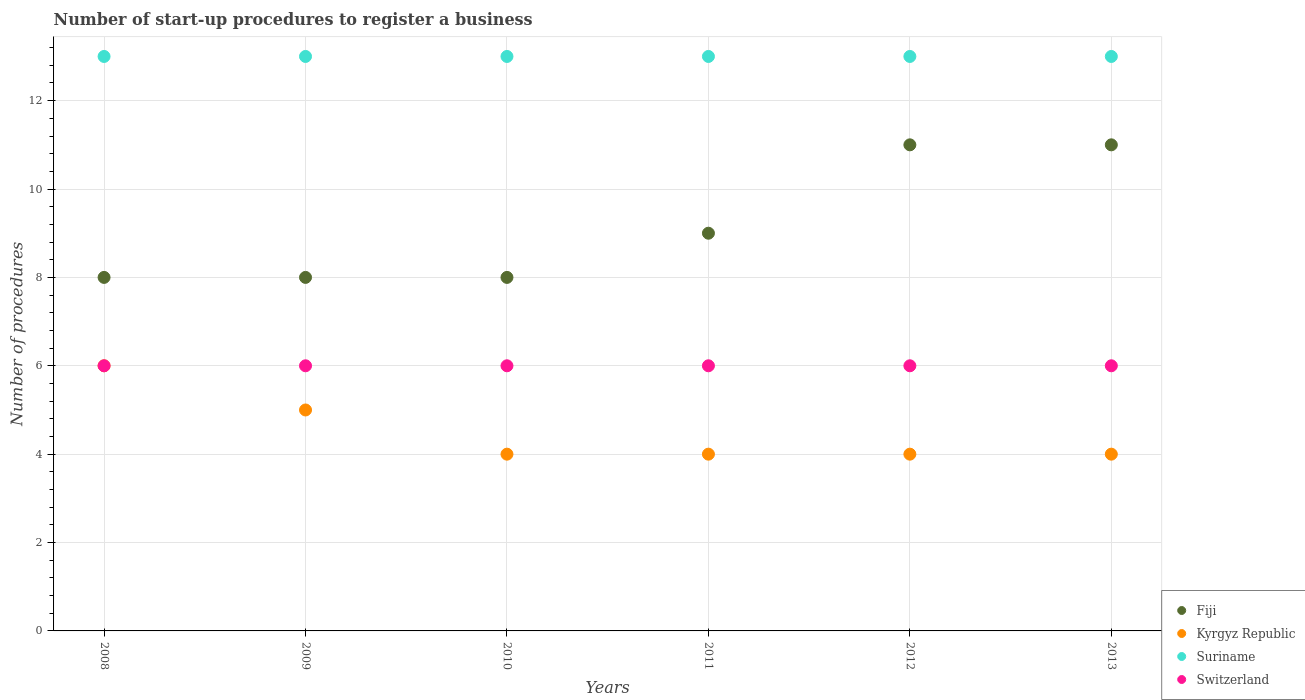How many different coloured dotlines are there?
Provide a short and direct response. 4. Is the number of dotlines equal to the number of legend labels?
Ensure brevity in your answer.  Yes. What is the number of procedures required to register a business in Fiji in 2010?
Make the answer very short. 8. Across all years, what is the minimum number of procedures required to register a business in Kyrgyz Republic?
Give a very brief answer. 4. In which year was the number of procedures required to register a business in Fiji minimum?
Give a very brief answer. 2008. What is the total number of procedures required to register a business in Switzerland in the graph?
Make the answer very short. 36. What is the difference between the number of procedures required to register a business in Suriname in 2009 and that in 2013?
Offer a terse response. 0. What is the difference between the number of procedures required to register a business in Fiji in 2013 and the number of procedures required to register a business in Switzerland in 2009?
Provide a succinct answer. 5. What is the average number of procedures required to register a business in Fiji per year?
Keep it short and to the point. 9.17. Is the number of procedures required to register a business in Fiji in 2011 less than that in 2012?
Provide a succinct answer. Yes. Is the difference between the number of procedures required to register a business in Switzerland in 2011 and 2013 greater than the difference between the number of procedures required to register a business in Suriname in 2011 and 2013?
Make the answer very short. No. What is the difference between the highest and the second highest number of procedures required to register a business in Suriname?
Give a very brief answer. 0. What is the difference between the highest and the lowest number of procedures required to register a business in Kyrgyz Republic?
Offer a very short reply. 2. In how many years, is the number of procedures required to register a business in Suriname greater than the average number of procedures required to register a business in Suriname taken over all years?
Give a very brief answer. 0. Is the sum of the number of procedures required to register a business in Switzerland in 2009 and 2013 greater than the maximum number of procedures required to register a business in Fiji across all years?
Provide a short and direct response. Yes. Is the number of procedures required to register a business in Kyrgyz Republic strictly greater than the number of procedures required to register a business in Switzerland over the years?
Provide a succinct answer. No. Is the number of procedures required to register a business in Kyrgyz Republic strictly less than the number of procedures required to register a business in Suriname over the years?
Provide a short and direct response. Yes. What is the difference between two consecutive major ticks on the Y-axis?
Your response must be concise. 2. Are the values on the major ticks of Y-axis written in scientific E-notation?
Ensure brevity in your answer.  No. Where does the legend appear in the graph?
Provide a succinct answer. Bottom right. How many legend labels are there?
Provide a short and direct response. 4. What is the title of the graph?
Your response must be concise. Number of start-up procedures to register a business. What is the label or title of the Y-axis?
Ensure brevity in your answer.  Number of procedures. What is the Number of procedures in Suriname in 2008?
Offer a terse response. 13. What is the Number of procedures of Kyrgyz Republic in 2009?
Your answer should be compact. 5. What is the Number of procedures in Suriname in 2009?
Keep it short and to the point. 13. What is the Number of procedures of Fiji in 2010?
Ensure brevity in your answer.  8. What is the Number of procedures in Suriname in 2010?
Your response must be concise. 13. What is the Number of procedures in Switzerland in 2010?
Provide a short and direct response. 6. What is the Number of procedures of Kyrgyz Republic in 2011?
Your response must be concise. 4. What is the Number of procedures in Suriname in 2011?
Provide a short and direct response. 13. What is the Number of procedures in Suriname in 2012?
Provide a succinct answer. 13. What is the Number of procedures in Switzerland in 2012?
Your response must be concise. 6. What is the Number of procedures in Fiji in 2013?
Your answer should be very brief. 11. Across all years, what is the maximum Number of procedures of Kyrgyz Republic?
Make the answer very short. 6. Across all years, what is the maximum Number of procedures in Suriname?
Your answer should be compact. 13. Across all years, what is the maximum Number of procedures of Switzerland?
Your answer should be compact. 6. Across all years, what is the minimum Number of procedures in Fiji?
Make the answer very short. 8. Across all years, what is the minimum Number of procedures in Switzerland?
Your answer should be very brief. 6. What is the total Number of procedures in Kyrgyz Republic in the graph?
Your response must be concise. 27. What is the total Number of procedures of Switzerland in the graph?
Provide a succinct answer. 36. What is the difference between the Number of procedures of Kyrgyz Republic in 2008 and that in 2009?
Your answer should be compact. 1. What is the difference between the Number of procedures in Suriname in 2008 and that in 2009?
Your answer should be compact. 0. What is the difference between the Number of procedures in Kyrgyz Republic in 2008 and that in 2010?
Provide a succinct answer. 2. What is the difference between the Number of procedures in Switzerland in 2008 and that in 2010?
Offer a very short reply. 0. What is the difference between the Number of procedures of Kyrgyz Republic in 2008 and that in 2011?
Offer a very short reply. 2. What is the difference between the Number of procedures of Suriname in 2008 and that in 2011?
Offer a terse response. 0. What is the difference between the Number of procedures in Switzerland in 2008 and that in 2012?
Your answer should be compact. 0. What is the difference between the Number of procedures in Kyrgyz Republic in 2008 and that in 2013?
Offer a terse response. 2. What is the difference between the Number of procedures in Suriname in 2008 and that in 2013?
Offer a terse response. 0. What is the difference between the Number of procedures of Switzerland in 2008 and that in 2013?
Provide a short and direct response. 0. What is the difference between the Number of procedures in Kyrgyz Republic in 2009 and that in 2010?
Your answer should be compact. 1. What is the difference between the Number of procedures of Switzerland in 2009 and that in 2010?
Give a very brief answer. 0. What is the difference between the Number of procedures in Kyrgyz Republic in 2009 and that in 2011?
Keep it short and to the point. 1. What is the difference between the Number of procedures of Suriname in 2009 and that in 2011?
Provide a short and direct response. 0. What is the difference between the Number of procedures in Switzerland in 2009 and that in 2011?
Provide a short and direct response. 0. What is the difference between the Number of procedures in Fiji in 2009 and that in 2012?
Your answer should be very brief. -3. What is the difference between the Number of procedures of Switzerland in 2009 and that in 2012?
Provide a succinct answer. 0. What is the difference between the Number of procedures of Fiji in 2009 and that in 2013?
Offer a very short reply. -3. What is the difference between the Number of procedures of Suriname in 2009 and that in 2013?
Ensure brevity in your answer.  0. What is the difference between the Number of procedures of Switzerland in 2009 and that in 2013?
Offer a terse response. 0. What is the difference between the Number of procedures of Fiji in 2010 and that in 2011?
Give a very brief answer. -1. What is the difference between the Number of procedures in Kyrgyz Republic in 2010 and that in 2011?
Make the answer very short. 0. What is the difference between the Number of procedures of Fiji in 2010 and that in 2012?
Make the answer very short. -3. What is the difference between the Number of procedures in Suriname in 2010 and that in 2012?
Keep it short and to the point. 0. What is the difference between the Number of procedures of Switzerland in 2010 and that in 2012?
Offer a terse response. 0. What is the difference between the Number of procedures in Suriname in 2010 and that in 2013?
Your response must be concise. 0. What is the difference between the Number of procedures in Switzerland in 2010 and that in 2013?
Keep it short and to the point. 0. What is the difference between the Number of procedures of Kyrgyz Republic in 2011 and that in 2012?
Offer a very short reply. 0. What is the difference between the Number of procedures in Switzerland in 2011 and that in 2013?
Provide a short and direct response. 0. What is the difference between the Number of procedures in Kyrgyz Republic in 2012 and that in 2013?
Ensure brevity in your answer.  0. What is the difference between the Number of procedures of Suriname in 2012 and that in 2013?
Offer a terse response. 0. What is the difference between the Number of procedures in Switzerland in 2012 and that in 2013?
Give a very brief answer. 0. What is the difference between the Number of procedures in Kyrgyz Republic in 2008 and the Number of procedures in Suriname in 2009?
Offer a terse response. -7. What is the difference between the Number of procedures in Kyrgyz Republic in 2008 and the Number of procedures in Switzerland in 2009?
Your answer should be compact. 0. What is the difference between the Number of procedures in Suriname in 2008 and the Number of procedures in Switzerland in 2009?
Provide a short and direct response. 7. What is the difference between the Number of procedures of Fiji in 2008 and the Number of procedures of Kyrgyz Republic in 2010?
Provide a short and direct response. 4. What is the difference between the Number of procedures in Kyrgyz Republic in 2008 and the Number of procedures in Switzerland in 2010?
Offer a terse response. 0. What is the difference between the Number of procedures of Suriname in 2008 and the Number of procedures of Switzerland in 2010?
Offer a terse response. 7. What is the difference between the Number of procedures of Fiji in 2008 and the Number of procedures of Kyrgyz Republic in 2011?
Ensure brevity in your answer.  4. What is the difference between the Number of procedures of Fiji in 2008 and the Number of procedures of Suriname in 2011?
Ensure brevity in your answer.  -5. What is the difference between the Number of procedures of Kyrgyz Republic in 2008 and the Number of procedures of Switzerland in 2011?
Ensure brevity in your answer.  0. What is the difference between the Number of procedures of Fiji in 2008 and the Number of procedures of Kyrgyz Republic in 2012?
Your response must be concise. 4. What is the difference between the Number of procedures of Kyrgyz Republic in 2008 and the Number of procedures of Suriname in 2012?
Offer a very short reply. -7. What is the difference between the Number of procedures in Kyrgyz Republic in 2008 and the Number of procedures in Switzerland in 2012?
Your answer should be compact. 0. What is the difference between the Number of procedures of Suriname in 2008 and the Number of procedures of Switzerland in 2012?
Provide a succinct answer. 7. What is the difference between the Number of procedures of Fiji in 2008 and the Number of procedures of Switzerland in 2013?
Make the answer very short. 2. What is the difference between the Number of procedures of Fiji in 2009 and the Number of procedures of Kyrgyz Republic in 2010?
Ensure brevity in your answer.  4. What is the difference between the Number of procedures of Fiji in 2009 and the Number of procedures of Suriname in 2010?
Your response must be concise. -5. What is the difference between the Number of procedures of Kyrgyz Republic in 2009 and the Number of procedures of Suriname in 2010?
Ensure brevity in your answer.  -8. What is the difference between the Number of procedures of Suriname in 2009 and the Number of procedures of Switzerland in 2010?
Your answer should be compact. 7. What is the difference between the Number of procedures of Fiji in 2009 and the Number of procedures of Switzerland in 2011?
Give a very brief answer. 2. What is the difference between the Number of procedures of Kyrgyz Republic in 2009 and the Number of procedures of Switzerland in 2011?
Offer a very short reply. -1. What is the difference between the Number of procedures in Suriname in 2009 and the Number of procedures in Switzerland in 2011?
Your answer should be compact. 7. What is the difference between the Number of procedures of Fiji in 2009 and the Number of procedures of Switzerland in 2012?
Give a very brief answer. 2. What is the difference between the Number of procedures in Kyrgyz Republic in 2009 and the Number of procedures in Suriname in 2012?
Give a very brief answer. -8. What is the difference between the Number of procedures of Suriname in 2009 and the Number of procedures of Switzerland in 2012?
Keep it short and to the point. 7. What is the difference between the Number of procedures of Fiji in 2009 and the Number of procedures of Suriname in 2013?
Your answer should be compact. -5. What is the difference between the Number of procedures in Fiji in 2009 and the Number of procedures in Switzerland in 2013?
Provide a succinct answer. 2. What is the difference between the Number of procedures of Kyrgyz Republic in 2009 and the Number of procedures of Suriname in 2013?
Ensure brevity in your answer.  -8. What is the difference between the Number of procedures in Kyrgyz Republic in 2009 and the Number of procedures in Switzerland in 2013?
Your response must be concise. -1. What is the difference between the Number of procedures of Suriname in 2009 and the Number of procedures of Switzerland in 2013?
Offer a terse response. 7. What is the difference between the Number of procedures in Kyrgyz Republic in 2010 and the Number of procedures in Switzerland in 2011?
Offer a terse response. -2. What is the difference between the Number of procedures in Fiji in 2010 and the Number of procedures in Kyrgyz Republic in 2012?
Ensure brevity in your answer.  4. What is the difference between the Number of procedures in Fiji in 2010 and the Number of procedures in Suriname in 2012?
Your answer should be very brief. -5. What is the difference between the Number of procedures of Kyrgyz Republic in 2010 and the Number of procedures of Suriname in 2012?
Offer a very short reply. -9. What is the difference between the Number of procedures of Suriname in 2010 and the Number of procedures of Switzerland in 2012?
Give a very brief answer. 7. What is the difference between the Number of procedures in Fiji in 2010 and the Number of procedures in Suriname in 2013?
Offer a terse response. -5. What is the difference between the Number of procedures in Fiji in 2010 and the Number of procedures in Switzerland in 2013?
Your answer should be compact. 2. What is the difference between the Number of procedures of Kyrgyz Republic in 2010 and the Number of procedures of Switzerland in 2013?
Provide a short and direct response. -2. What is the difference between the Number of procedures in Fiji in 2011 and the Number of procedures in Suriname in 2012?
Your answer should be compact. -4. What is the difference between the Number of procedures in Fiji in 2011 and the Number of procedures in Switzerland in 2012?
Offer a very short reply. 3. What is the difference between the Number of procedures of Kyrgyz Republic in 2011 and the Number of procedures of Suriname in 2012?
Your response must be concise. -9. What is the difference between the Number of procedures of Suriname in 2011 and the Number of procedures of Switzerland in 2012?
Ensure brevity in your answer.  7. What is the difference between the Number of procedures of Kyrgyz Republic in 2011 and the Number of procedures of Switzerland in 2013?
Your response must be concise. -2. What is the difference between the Number of procedures of Fiji in 2012 and the Number of procedures of Switzerland in 2013?
Your response must be concise. 5. What is the difference between the Number of procedures in Kyrgyz Republic in 2012 and the Number of procedures in Suriname in 2013?
Ensure brevity in your answer.  -9. What is the difference between the Number of procedures in Kyrgyz Republic in 2012 and the Number of procedures in Switzerland in 2013?
Ensure brevity in your answer.  -2. What is the average Number of procedures of Fiji per year?
Your answer should be very brief. 9.17. What is the average Number of procedures in Switzerland per year?
Keep it short and to the point. 6. In the year 2008, what is the difference between the Number of procedures of Fiji and Number of procedures of Suriname?
Your response must be concise. -5. In the year 2008, what is the difference between the Number of procedures of Kyrgyz Republic and Number of procedures of Suriname?
Make the answer very short. -7. In the year 2008, what is the difference between the Number of procedures in Kyrgyz Republic and Number of procedures in Switzerland?
Your response must be concise. 0. In the year 2008, what is the difference between the Number of procedures of Suriname and Number of procedures of Switzerland?
Provide a succinct answer. 7. In the year 2009, what is the difference between the Number of procedures of Fiji and Number of procedures of Suriname?
Provide a short and direct response. -5. In the year 2009, what is the difference between the Number of procedures in Kyrgyz Republic and Number of procedures in Suriname?
Provide a succinct answer. -8. In the year 2009, what is the difference between the Number of procedures of Kyrgyz Republic and Number of procedures of Switzerland?
Give a very brief answer. -1. In the year 2009, what is the difference between the Number of procedures of Suriname and Number of procedures of Switzerland?
Your answer should be very brief. 7. In the year 2010, what is the difference between the Number of procedures in Fiji and Number of procedures in Kyrgyz Republic?
Give a very brief answer. 4. In the year 2010, what is the difference between the Number of procedures of Fiji and Number of procedures of Suriname?
Provide a short and direct response. -5. In the year 2010, what is the difference between the Number of procedures in Kyrgyz Republic and Number of procedures in Suriname?
Give a very brief answer. -9. In the year 2010, what is the difference between the Number of procedures in Suriname and Number of procedures in Switzerland?
Your response must be concise. 7. In the year 2011, what is the difference between the Number of procedures of Fiji and Number of procedures of Switzerland?
Your answer should be very brief. 3. In the year 2011, what is the difference between the Number of procedures in Kyrgyz Republic and Number of procedures in Suriname?
Make the answer very short. -9. In the year 2011, what is the difference between the Number of procedures in Suriname and Number of procedures in Switzerland?
Your response must be concise. 7. In the year 2012, what is the difference between the Number of procedures in Fiji and Number of procedures in Kyrgyz Republic?
Give a very brief answer. 7. In the year 2012, what is the difference between the Number of procedures of Fiji and Number of procedures of Suriname?
Keep it short and to the point. -2. In the year 2012, what is the difference between the Number of procedures in Fiji and Number of procedures in Switzerland?
Your response must be concise. 5. In the year 2013, what is the difference between the Number of procedures in Fiji and Number of procedures in Kyrgyz Republic?
Give a very brief answer. 7. In the year 2013, what is the difference between the Number of procedures in Fiji and Number of procedures in Suriname?
Your answer should be compact. -2. In the year 2013, what is the difference between the Number of procedures of Kyrgyz Republic and Number of procedures of Suriname?
Offer a terse response. -9. In the year 2013, what is the difference between the Number of procedures of Kyrgyz Republic and Number of procedures of Switzerland?
Offer a terse response. -2. In the year 2013, what is the difference between the Number of procedures of Suriname and Number of procedures of Switzerland?
Offer a very short reply. 7. What is the ratio of the Number of procedures of Kyrgyz Republic in 2008 to that in 2009?
Make the answer very short. 1.2. What is the ratio of the Number of procedures of Suriname in 2008 to that in 2009?
Give a very brief answer. 1. What is the ratio of the Number of procedures of Suriname in 2008 to that in 2010?
Your answer should be compact. 1. What is the ratio of the Number of procedures of Switzerland in 2008 to that in 2010?
Keep it short and to the point. 1. What is the ratio of the Number of procedures of Kyrgyz Republic in 2008 to that in 2011?
Offer a very short reply. 1.5. What is the ratio of the Number of procedures in Suriname in 2008 to that in 2011?
Your response must be concise. 1. What is the ratio of the Number of procedures in Switzerland in 2008 to that in 2011?
Offer a terse response. 1. What is the ratio of the Number of procedures of Fiji in 2008 to that in 2012?
Give a very brief answer. 0.73. What is the ratio of the Number of procedures of Fiji in 2008 to that in 2013?
Provide a succinct answer. 0.73. What is the ratio of the Number of procedures of Kyrgyz Republic in 2008 to that in 2013?
Provide a short and direct response. 1.5. What is the ratio of the Number of procedures of Switzerland in 2009 to that in 2010?
Your response must be concise. 1. What is the ratio of the Number of procedures of Suriname in 2009 to that in 2011?
Give a very brief answer. 1. What is the ratio of the Number of procedures of Switzerland in 2009 to that in 2011?
Your response must be concise. 1. What is the ratio of the Number of procedures in Fiji in 2009 to that in 2012?
Offer a terse response. 0.73. What is the ratio of the Number of procedures in Switzerland in 2009 to that in 2012?
Provide a short and direct response. 1. What is the ratio of the Number of procedures in Fiji in 2009 to that in 2013?
Give a very brief answer. 0.73. What is the ratio of the Number of procedures of Kyrgyz Republic in 2009 to that in 2013?
Offer a very short reply. 1.25. What is the ratio of the Number of procedures of Switzerland in 2009 to that in 2013?
Ensure brevity in your answer.  1. What is the ratio of the Number of procedures of Kyrgyz Republic in 2010 to that in 2011?
Give a very brief answer. 1. What is the ratio of the Number of procedures of Suriname in 2010 to that in 2011?
Offer a terse response. 1. What is the ratio of the Number of procedures of Fiji in 2010 to that in 2012?
Make the answer very short. 0.73. What is the ratio of the Number of procedures of Suriname in 2010 to that in 2012?
Your answer should be compact. 1. What is the ratio of the Number of procedures of Switzerland in 2010 to that in 2012?
Make the answer very short. 1. What is the ratio of the Number of procedures in Fiji in 2010 to that in 2013?
Your answer should be compact. 0.73. What is the ratio of the Number of procedures of Switzerland in 2010 to that in 2013?
Offer a terse response. 1. What is the ratio of the Number of procedures of Fiji in 2011 to that in 2012?
Keep it short and to the point. 0.82. What is the ratio of the Number of procedures of Kyrgyz Republic in 2011 to that in 2012?
Your answer should be compact. 1. What is the ratio of the Number of procedures of Suriname in 2011 to that in 2012?
Your answer should be compact. 1. What is the ratio of the Number of procedures of Fiji in 2011 to that in 2013?
Your answer should be very brief. 0.82. What is the ratio of the Number of procedures of Suriname in 2011 to that in 2013?
Your answer should be very brief. 1. What is the ratio of the Number of procedures of Fiji in 2012 to that in 2013?
Ensure brevity in your answer.  1. What is the ratio of the Number of procedures of Kyrgyz Republic in 2012 to that in 2013?
Keep it short and to the point. 1. What is the ratio of the Number of procedures in Suriname in 2012 to that in 2013?
Provide a succinct answer. 1. What is the difference between the highest and the second highest Number of procedures of Suriname?
Keep it short and to the point. 0. What is the difference between the highest and the lowest Number of procedures in Fiji?
Keep it short and to the point. 3. What is the difference between the highest and the lowest Number of procedures of Kyrgyz Republic?
Offer a very short reply. 2. What is the difference between the highest and the lowest Number of procedures of Suriname?
Give a very brief answer. 0. What is the difference between the highest and the lowest Number of procedures in Switzerland?
Make the answer very short. 0. 